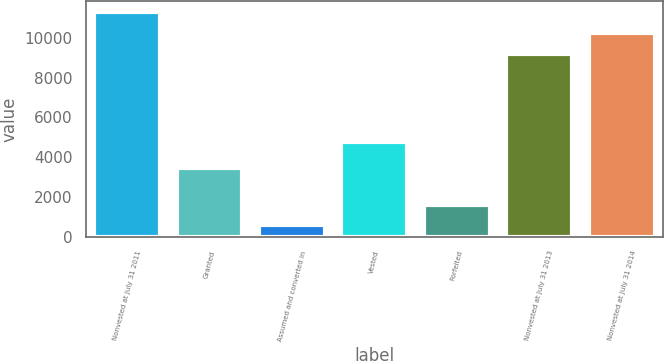Convert chart to OTSL. <chart><loc_0><loc_0><loc_500><loc_500><bar_chart><fcel>Nonvested at July 31 2011<fcel>Granted<fcel>Assumed and converted in<fcel>Vested<fcel>Forfeited<fcel>Nonvested at July 31 2013<fcel>Nonvested at July 31 2014<nl><fcel>11280<fcel>3436<fcel>575<fcel>4763<fcel>1623<fcel>9184<fcel>10232<nl></chart> 